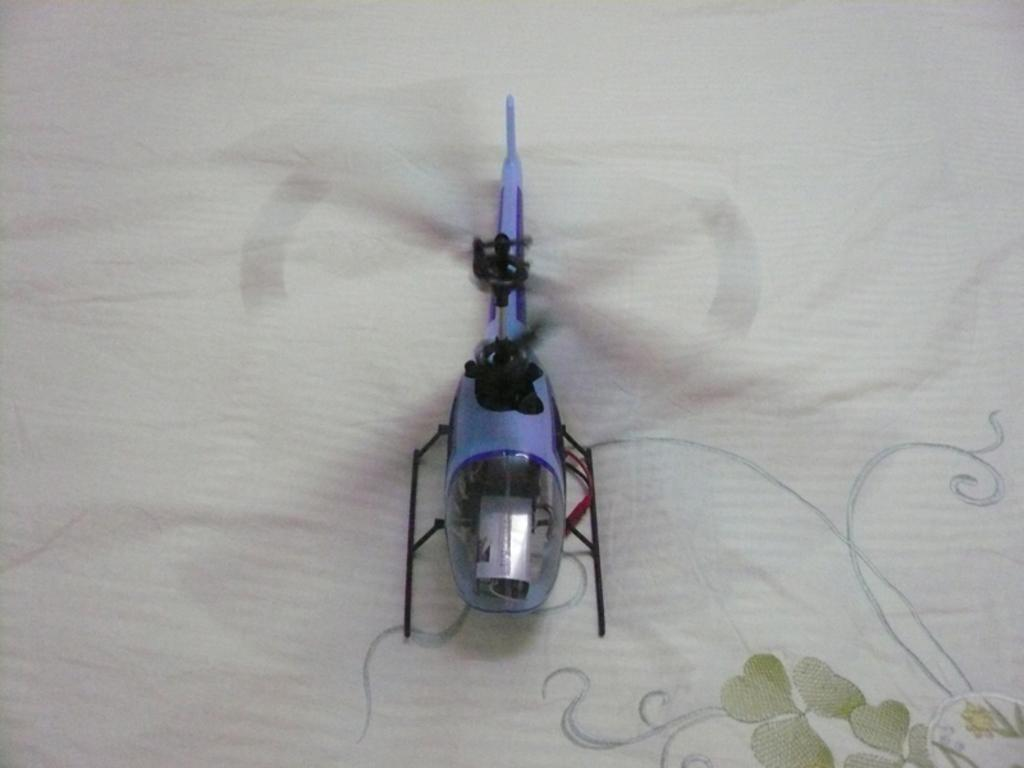What is the main subject of the image? The main subject of the image is a toy helicopter. What is the toy helicopter placed on in the image? The toy helicopter is placed on a cloth. Who is the owner of the toy helicopter in the image? There is no information about the owner of the toy helicopter in the image. What is the tax rate for toy helicopters in the image? There is no information about tax rates for toy helicopters in the image. 